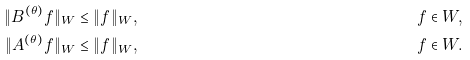Convert formula to latex. <formula><loc_0><loc_0><loc_500><loc_500>\| B ^ { ( \theta ) } f \| _ { W } & \leq \| f \| _ { W } , & & f \in W , \\ \| A ^ { ( \theta ) } f \| _ { W } & \leq \| f \| _ { W } , & & f \in W .</formula> 